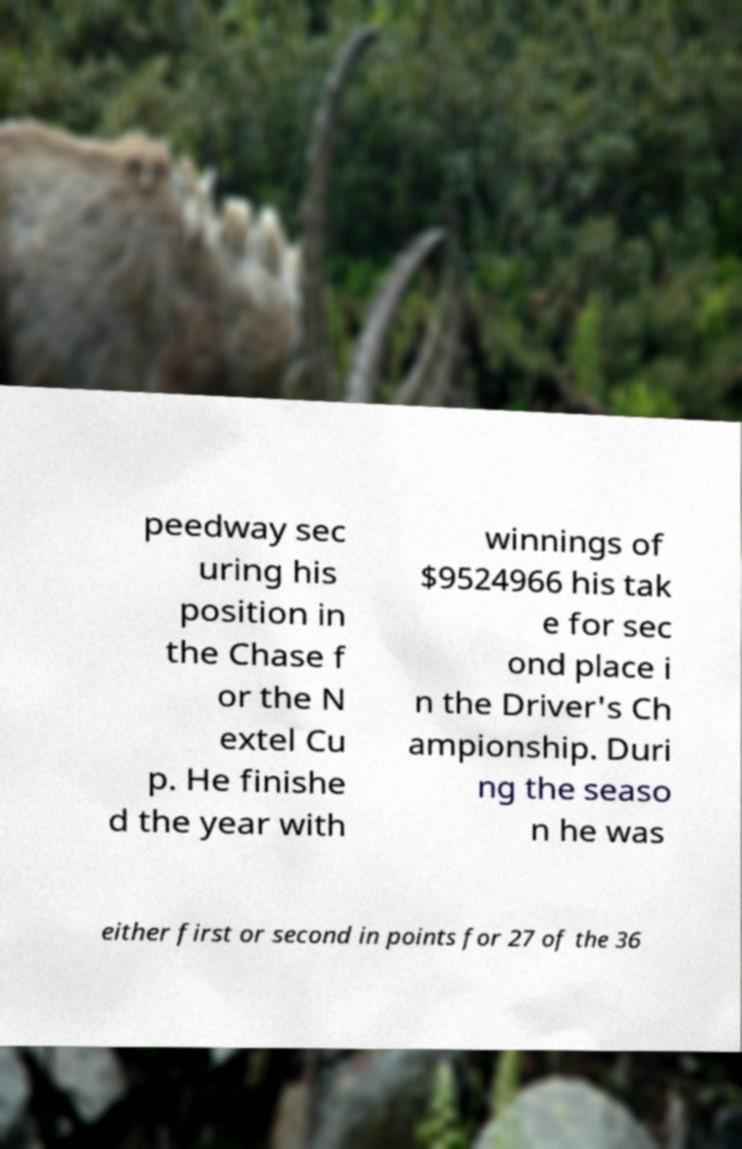For documentation purposes, I need the text within this image transcribed. Could you provide that? peedway sec uring his position in the Chase f or the N extel Cu p. He finishe d the year with winnings of $9524966 his tak e for sec ond place i n the Driver's Ch ampionship. Duri ng the seaso n he was either first or second in points for 27 of the 36 